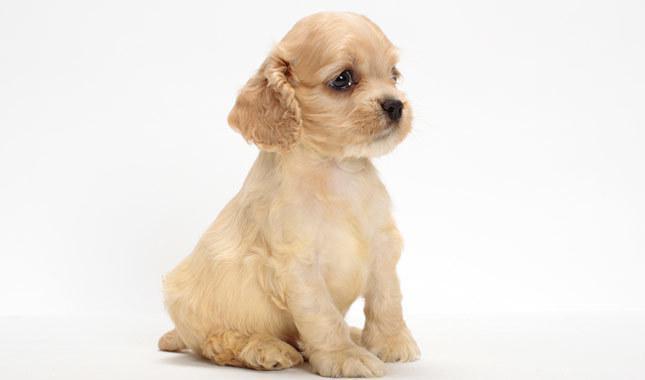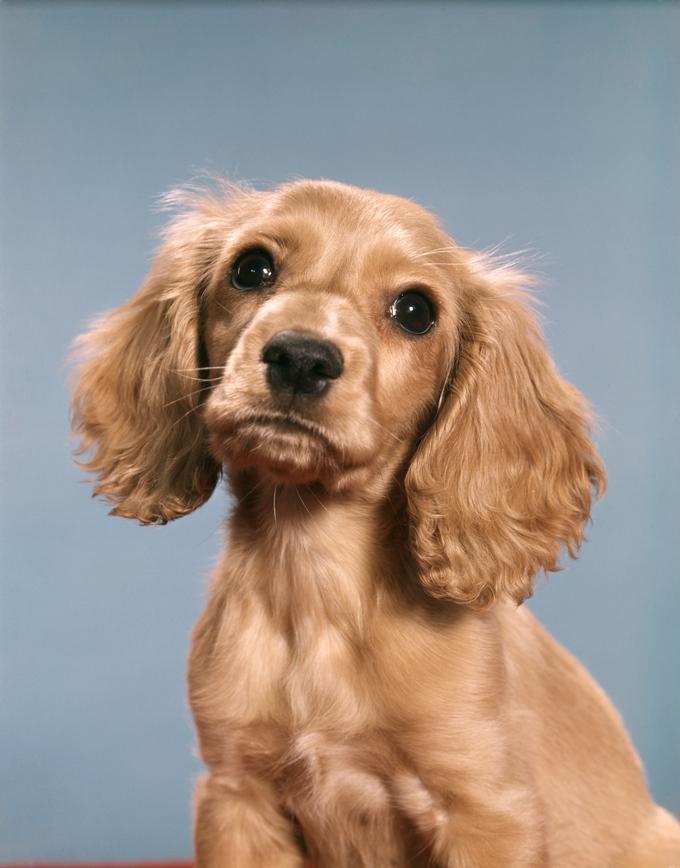The first image is the image on the left, the second image is the image on the right. Evaluate the accuracy of this statement regarding the images: "One image has a colored background, while the other is white, they are not the same.". Is it true? Answer yes or no. Yes. 